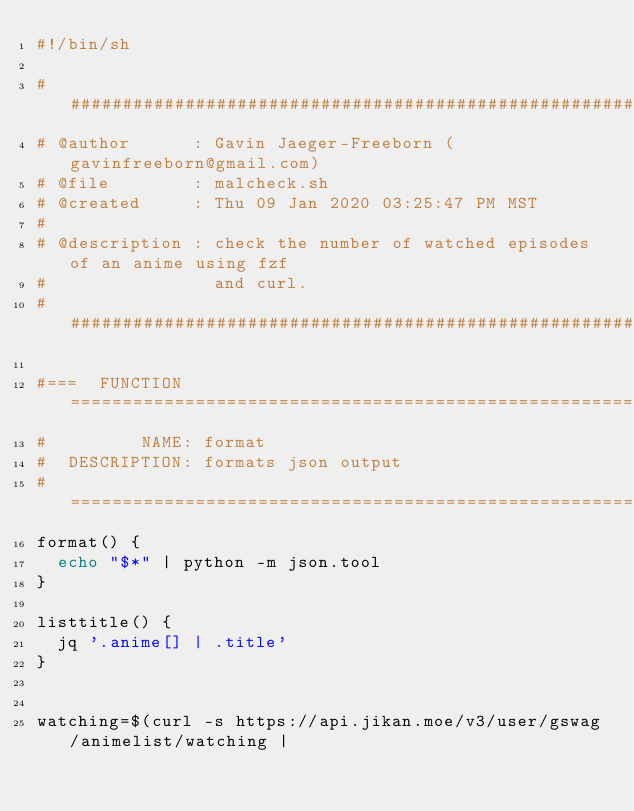<code> <loc_0><loc_0><loc_500><loc_500><_Bash_>#!/bin/sh

######################################################################
# @author      : Gavin Jaeger-Freeborn (gavinfreeborn@gmail.com)
# @file        : malcheck.sh
# @created     : Thu 09 Jan 2020 03:25:47 PM MST
#
# @description : check the number of watched episodes of an anime using fzf
#                and curl.
######################################################################

#===  FUNCTION  ======================================================
#         NAME: format
#  DESCRIPTION: formats json output
#=====================================================================
format() {
  echo "$*" | python -m json.tool
}

listtitle() {
  jq '.anime[] | .title'
}


watching=$(curl -s https://api.jikan.moe/v3/user/gswag/animelist/watching |</code> 